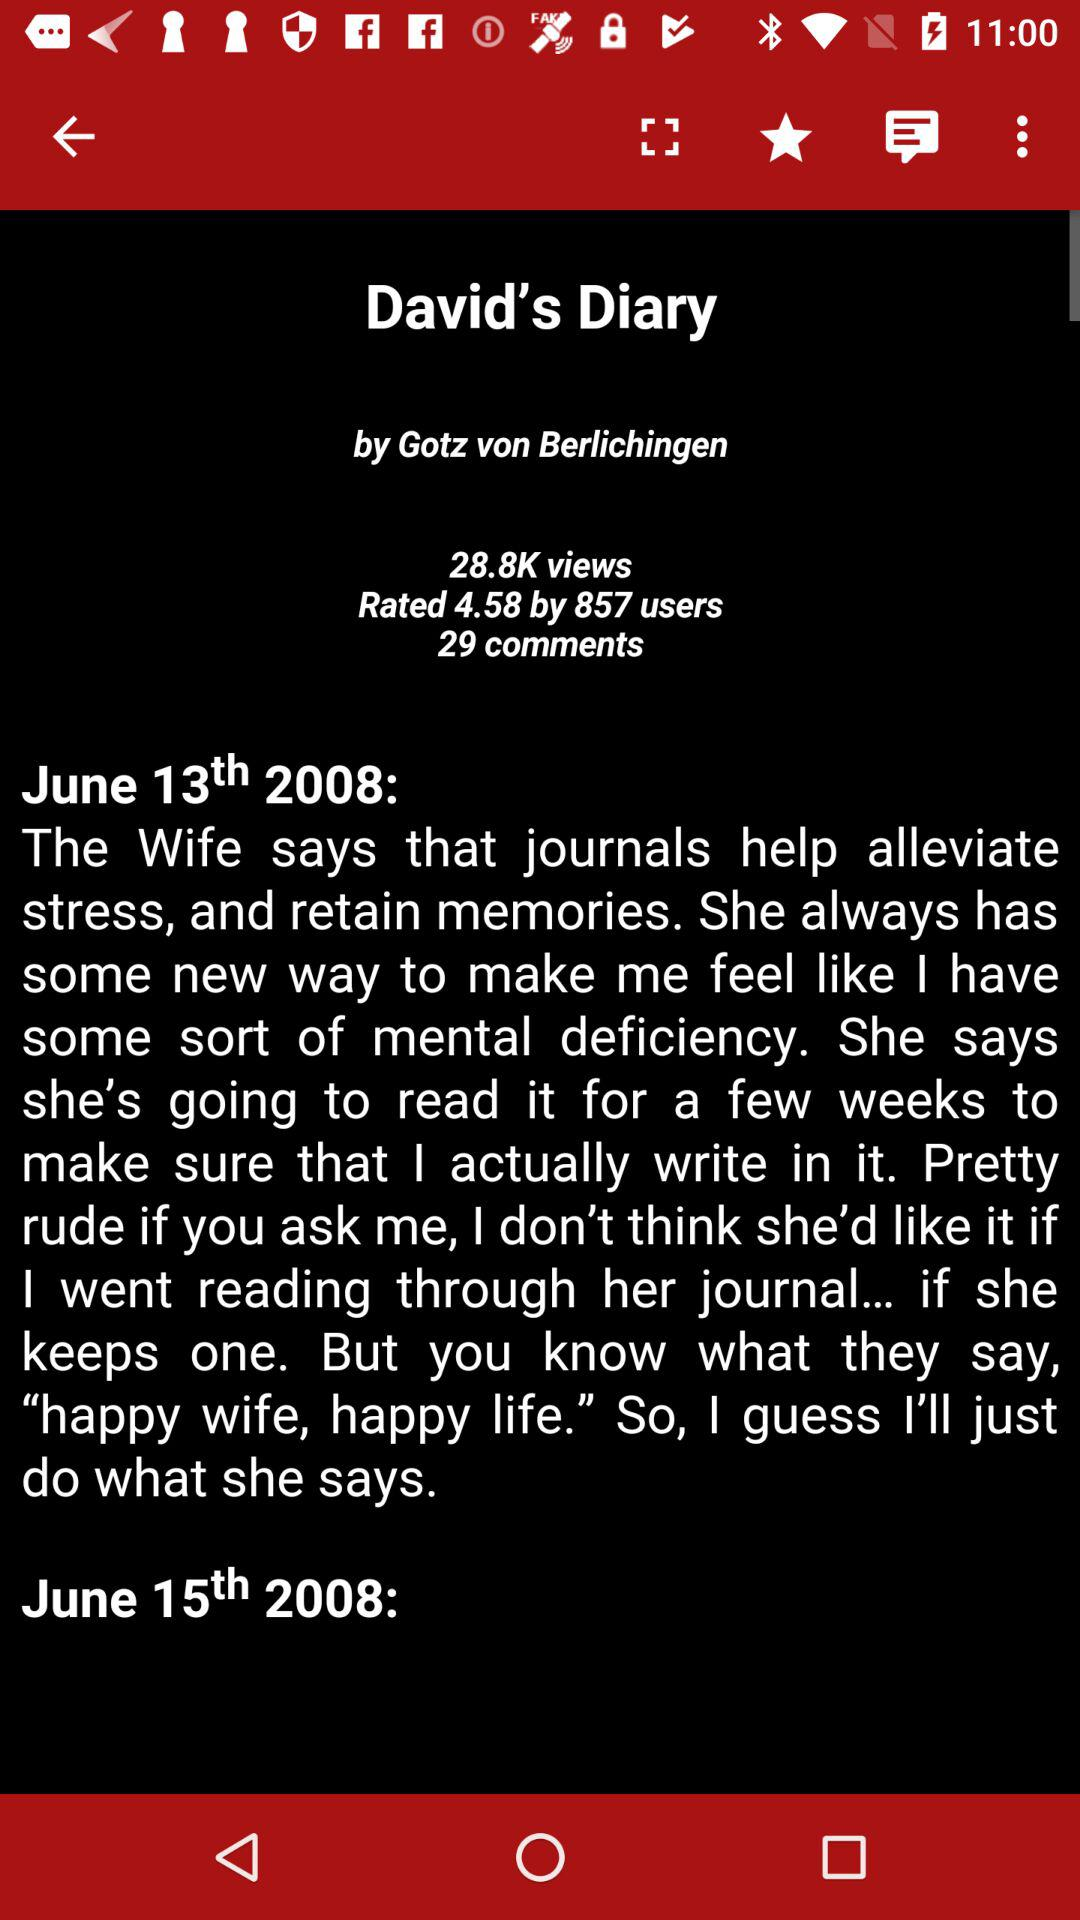How many days apart are the two entries?
Answer the question using a single word or phrase. 2 